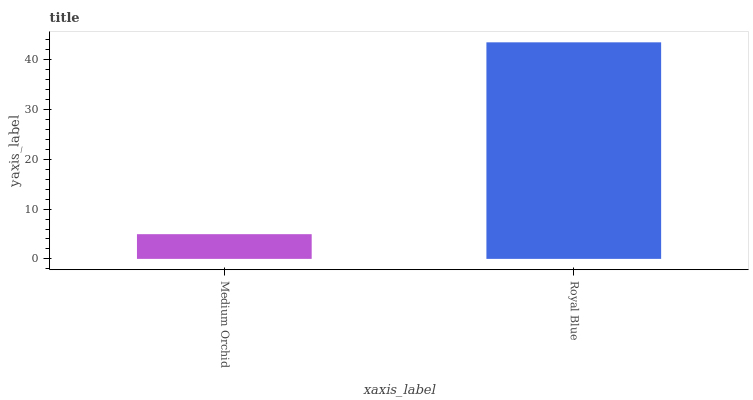Is Medium Orchid the minimum?
Answer yes or no. Yes. Is Royal Blue the maximum?
Answer yes or no. Yes. Is Royal Blue the minimum?
Answer yes or no. No. Is Royal Blue greater than Medium Orchid?
Answer yes or no. Yes. Is Medium Orchid less than Royal Blue?
Answer yes or no. Yes. Is Medium Orchid greater than Royal Blue?
Answer yes or no. No. Is Royal Blue less than Medium Orchid?
Answer yes or no. No. Is Royal Blue the high median?
Answer yes or no. Yes. Is Medium Orchid the low median?
Answer yes or no. Yes. Is Medium Orchid the high median?
Answer yes or no. No. Is Royal Blue the low median?
Answer yes or no. No. 